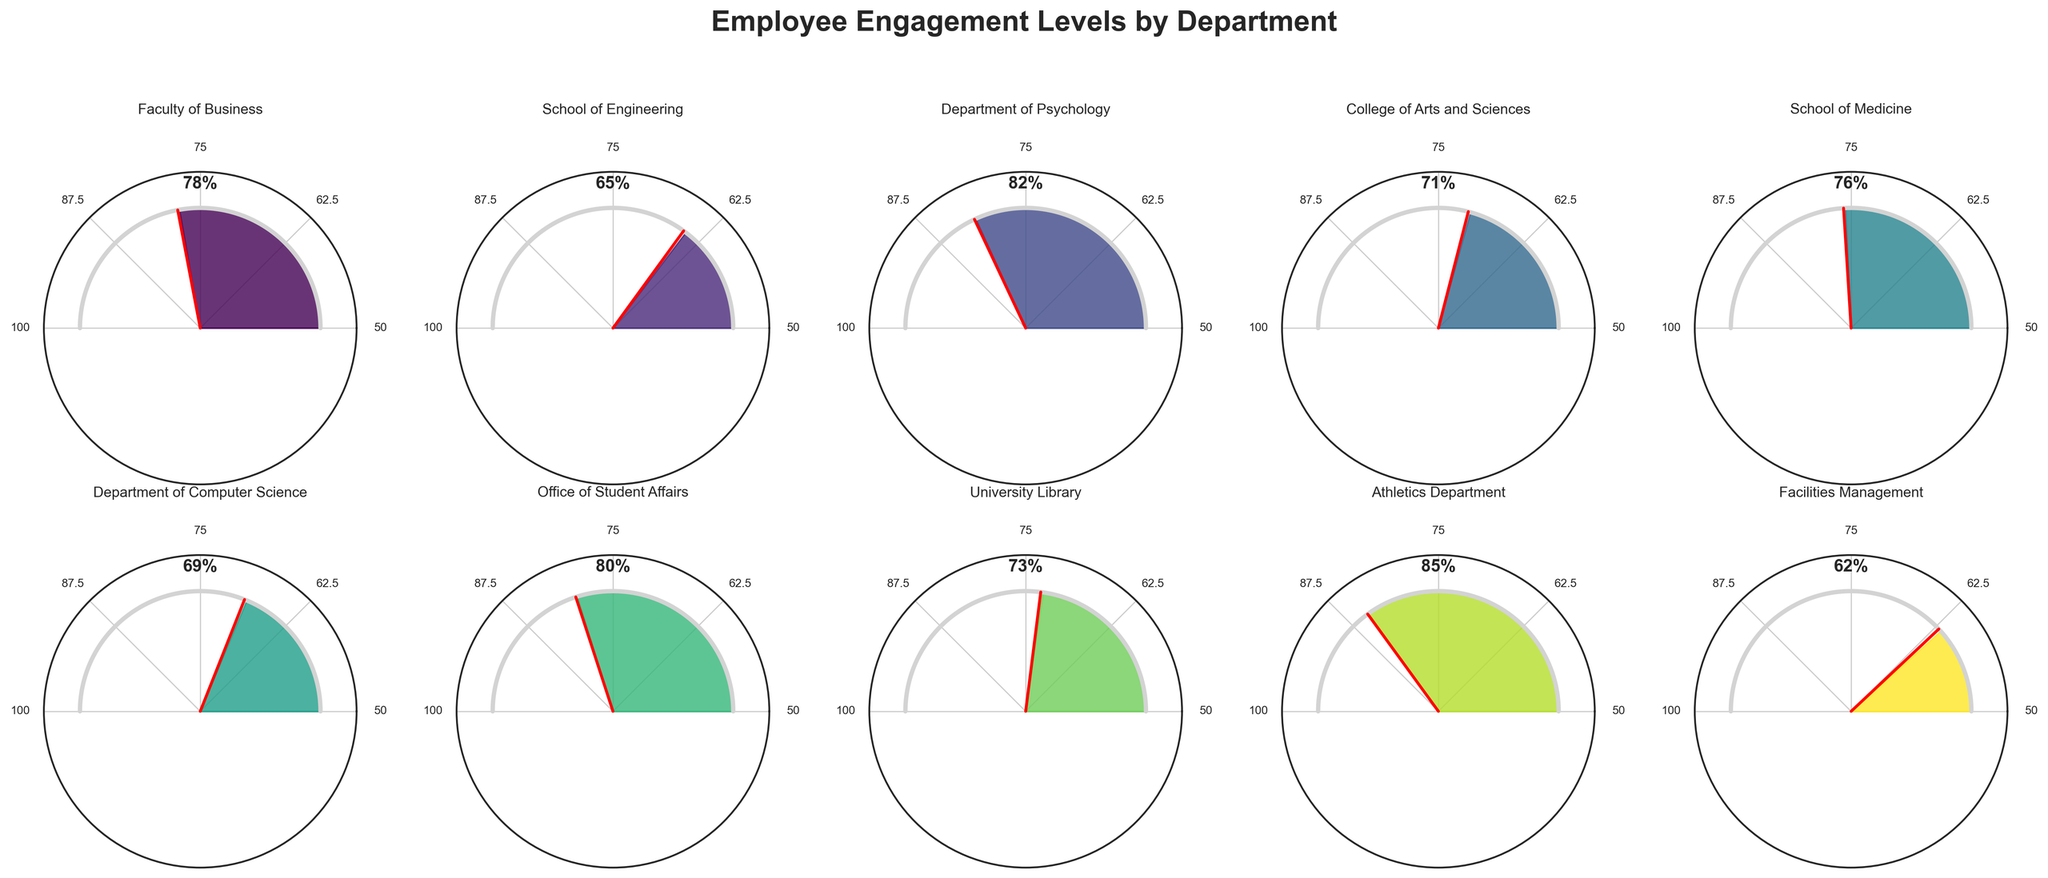What is the highest employee engagement level among the departments? The highest engagement level can be identified by looking at the values provided for each department and selecting the maximum value. From the data, the highest value is 85% in the Athletics Department.
Answer: 85% What is the title of the figure? The title of the figure is displayed at the top of the plot. It reads "Employee Engagement Levels by Department" as seen in the provided data for plotting the figure.
Answer: Employee Engagement Levels by Department Which department has the lowest engagement level? To find the lowest engagement level, we compare the engagement levels of all departments and identify the smallest value. The lowest level is 62% from the Facilities Management department.
Answer: Facilities Management What are the engagement levels of the School of Engineering and the University Library, and how do they compare? The School of Engineering has an engagement level of 65% and the University Library has an engagement level of 73%. Comparing these, the University Library has a higher engagement level.
Answer: School of Engineering: 65%, University Library: 73% How many departments have an engagement level above 75%? To answer this, count the number of departments whose engagement levels are above 75%. The departments are Faculty of Business (78%), Department of Psychology (82%), School of Medicine (76%), Office of Student Affairs (80%), and Athletics Department (85%). There are 5 departments.
Answer: 5 What is the average engagement level across all departments? To find the average, sum up all the engagement levels and divide by the number of departments. Calculation: (78 + 65 + 82 + 71 + 76 + 69 + 80 + 73 + 85 + 62) / 10 = 74.1%
Answer: 74.1% Which departments have an engagement level between 70% and 80%? Identify the departments whose engagement levels fall within the specified range. The relevant departments are Faculty of Business (78%), College of Arts and Sciences (71%), School of Medicine (76%), and University Library (73%).
Answer: Faculty of Business, College of Arts and Sciences, School of Medicine, University Library Is the engagement level of the Department of Psychology closer to 50% or 100%? The engagement level of the Department of Psychology is 82%. The closer threshold can be determined by seeing its distance to 50% and 100%. Calculation: 82 - 50 = 32 and 100 - 82 = 18. It is closer to 100%.
Answer: 100% Which department has an engagement level closest to the overall average? First, calculate the overall average, which is 74.1%. Then compare each department's engagement level to this average and find the nearest value. University Library with 73% is the closest to 74.1%.
Answer: University Library 